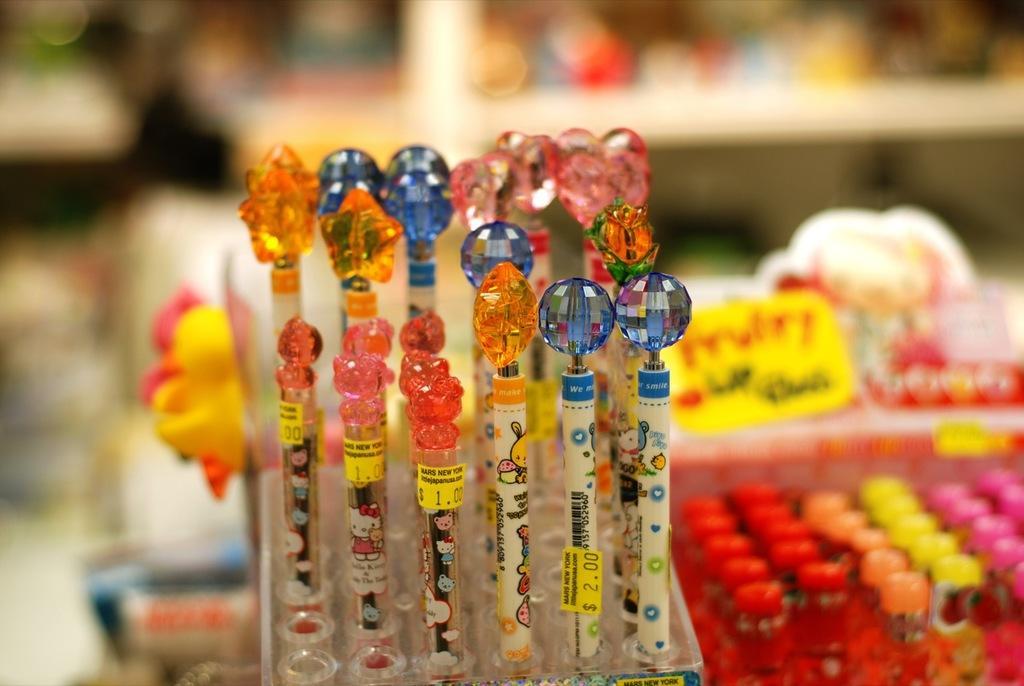Can you describe this image briefly? In this picture I can see pens with stickers, there are some objects, and there is blur background. 